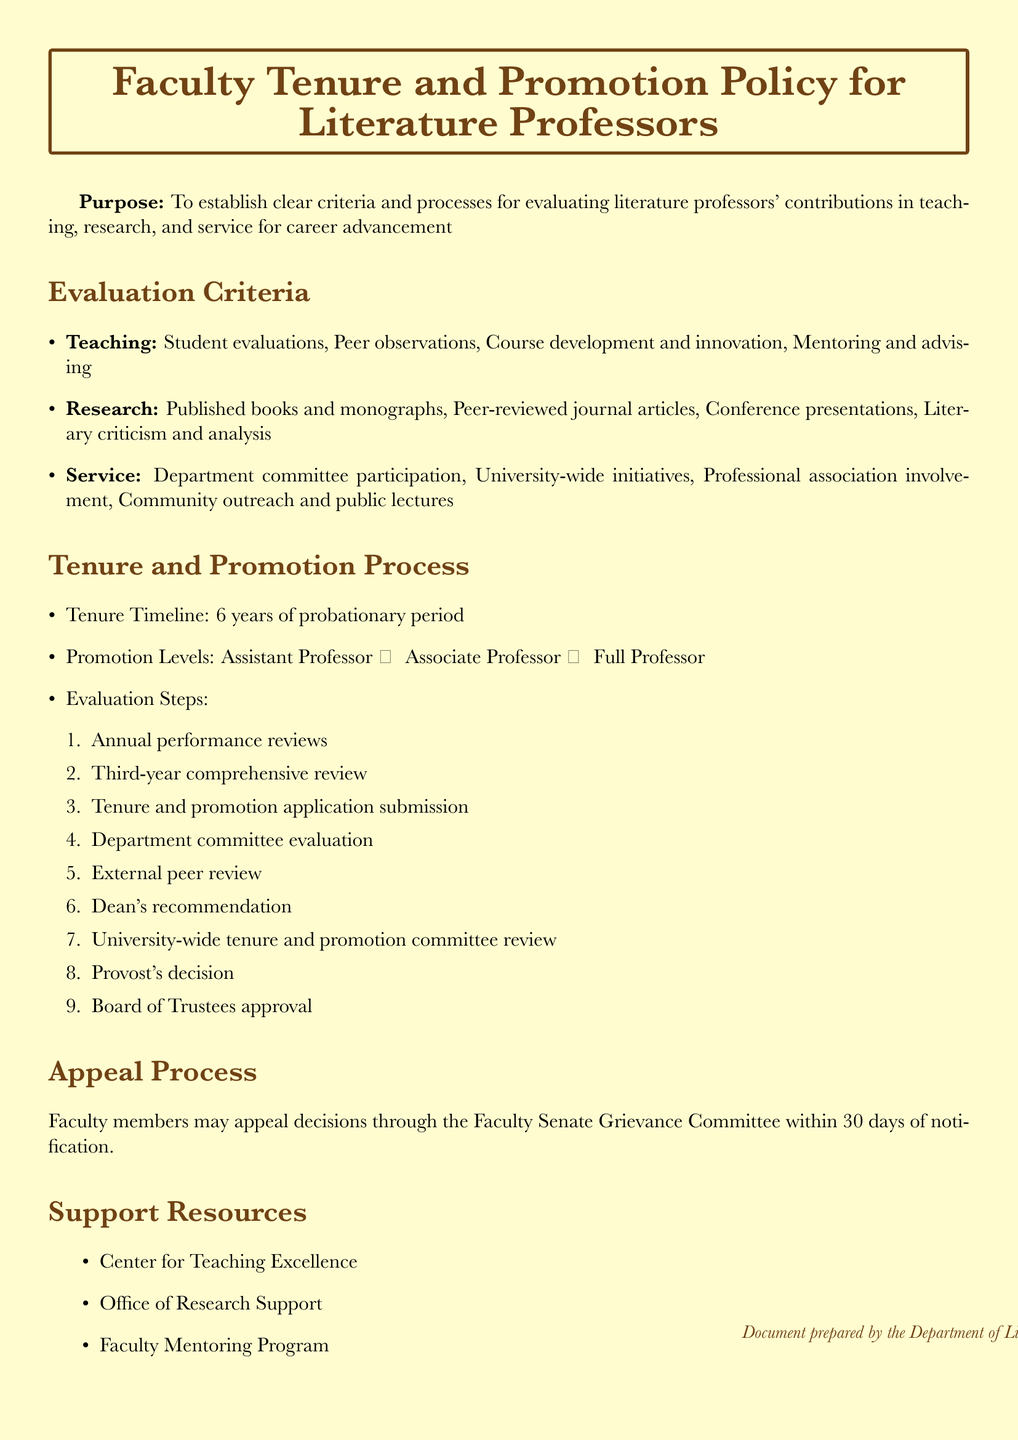What is the purpose of the document? The purpose of the document is stated clearly at the beginning, focusing on establishing criteria and processes for evaluating contributions.
Answer: To establish clear criteria and processes for evaluating literature professors' contributions in teaching, research, and service for career advancement How long is the tenure timeline? The tenure timeline is specified in the document as the duration of the probationary period for faculty members.
Answer: 6 years What are the three main areas evaluated for faculty tenure and promotion? The document lists the three main areas of evaluation under the section "Evaluation Criteria."
Answer: Teaching, research, and service Which professor rank comes after Assistant Professor? The ranks for promotion are listed in the "Promotion Levels" section of the document.
Answer: Associate Professor How many steps are there in the evaluation process? The number of steps in the evaluation process is indicated in the enumerated list within the "Evaluation Steps" section.
Answer: 9 What can faculty members do if they want to appeal a decision? The document describes the process for appealing decisions within a specific timeframe after notification.
Answer: Appeal through the Faculty Senate Grievance Committee Which center is mentioned as a support resource? The document provides examples of support resources available to faculty, listing specific centers and programs.
Answer: Center for Teaching Excellence 